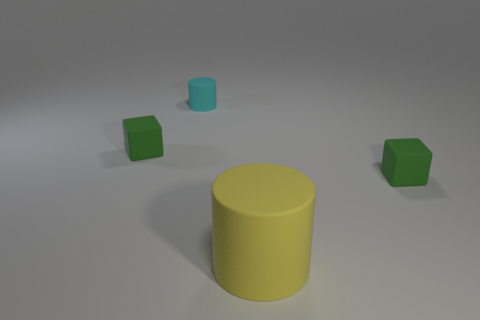What number of other things are there of the same color as the small cylinder?
Keep it short and to the point. 0. Does the cylinder that is behind the large matte object have the same material as the big yellow cylinder?
Provide a succinct answer. Yes. Are there any other things that have the same size as the yellow cylinder?
Your answer should be compact. No. Are there fewer rubber blocks that are in front of the big yellow cylinder than large cylinders that are on the right side of the tiny matte cylinder?
Your answer should be compact. Yes. Is there anything else that is the same shape as the small cyan thing?
Your response must be concise. Yes. There is a green rubber block that is in front of the block that is left of the yellow matte cylinder; what number of tiny green blocks are behind it?
Give a very brief answer. 1. There is a big matte cylinder; how many matte things are on the right side of it?
Offer a very short reply. 1. How many green objects are the same material as the small cyan cylinder?
Your answer should be very brief. 2. What color is the big thing that is the same material as the cyan cylinder?
Make the answer very short. Yellow. There is a cylinder that is behind the green rubber cube that is to the left of the matte cube right of the tiny cyan rubber thing; what is its material?
Your answer should be very brief. Rubber. 